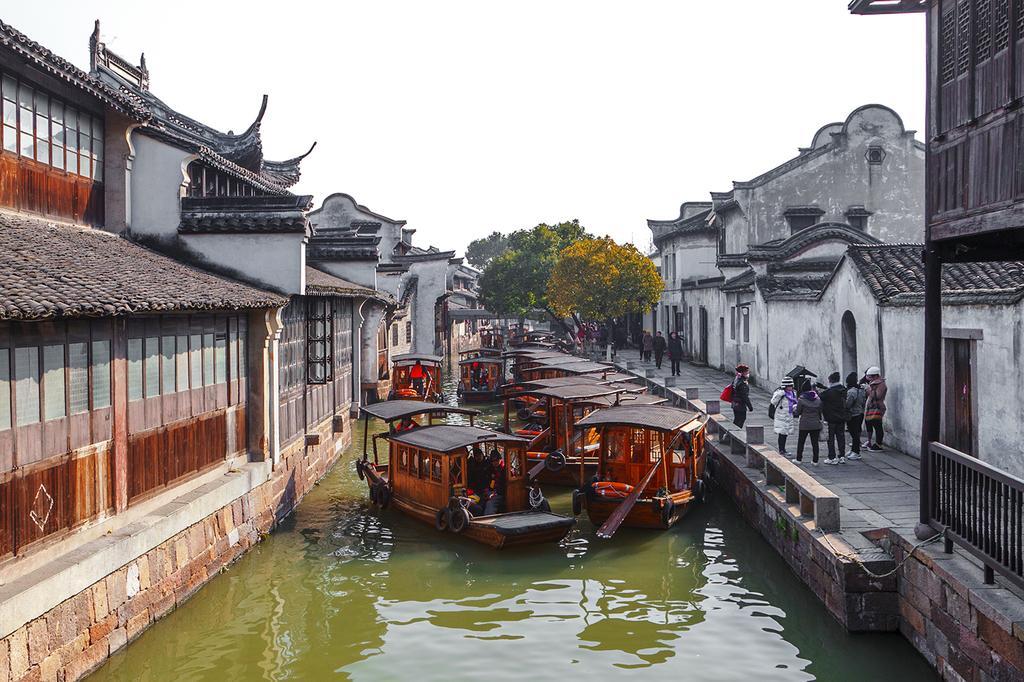Describe this image in one or two sentences. In this image we can see boats on the water. On the sides there are buildings with windows and doors. Also we can see people on the sidewalk. Also there are railings. In the back there are trees. And there is sky. 